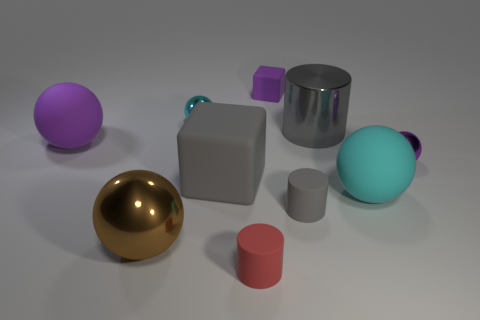What shapes and colors are the objects in this image? The image features a variety of shapes and colors. There is a purple spherical object, a golden sphere, a cyan ovoid shape, a shiny silver cylinder, a grayish cube, a small lavender cube, a smaller gray cylinder, and a pinkish short cylinder. 